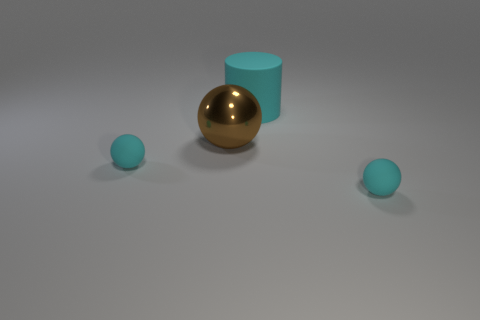Is the cyan object that is behind the large brown shiny ball made of the same material as the small sphere that is to the left of the big matte cylinder?
Provide a short and direct response. Yes. What is the material of the brown ball behind the small cyan object that is on the right side of the metal sphere?
Keep it short and to the point. Metal. What is the shape of the cyan thing that is in front of the small cyan sphere left of the ball that is to the right of the large cylinder?
Provide a succinct answer. Sphere. How many purple metallic cylinders are there?
Offer a very short reply. 0. What is the shape of the small cyan matte object on the right side of the brown metallic object?
Keep it short and to the point. Sphere. What is the color of the metal ball that is behind the rubber ball in front of the tiny rubber ball that is left of the cyan matte cylinder?
Give a very brief answer. Brown. Is the number of large brown things less than the number of small things?
Provide a succinct answer. Yes. Is the material of the large brown thing the same as the cyan cylinder?
Ensure brevity in your answer.  No. How many other objects are there of the same color as the big rubber cylinder?
Make the answer very short. 2. Is the number of brown metal spheres greater than the number of small purple metallic cylinders?
Offer a very short reply. Yes. 